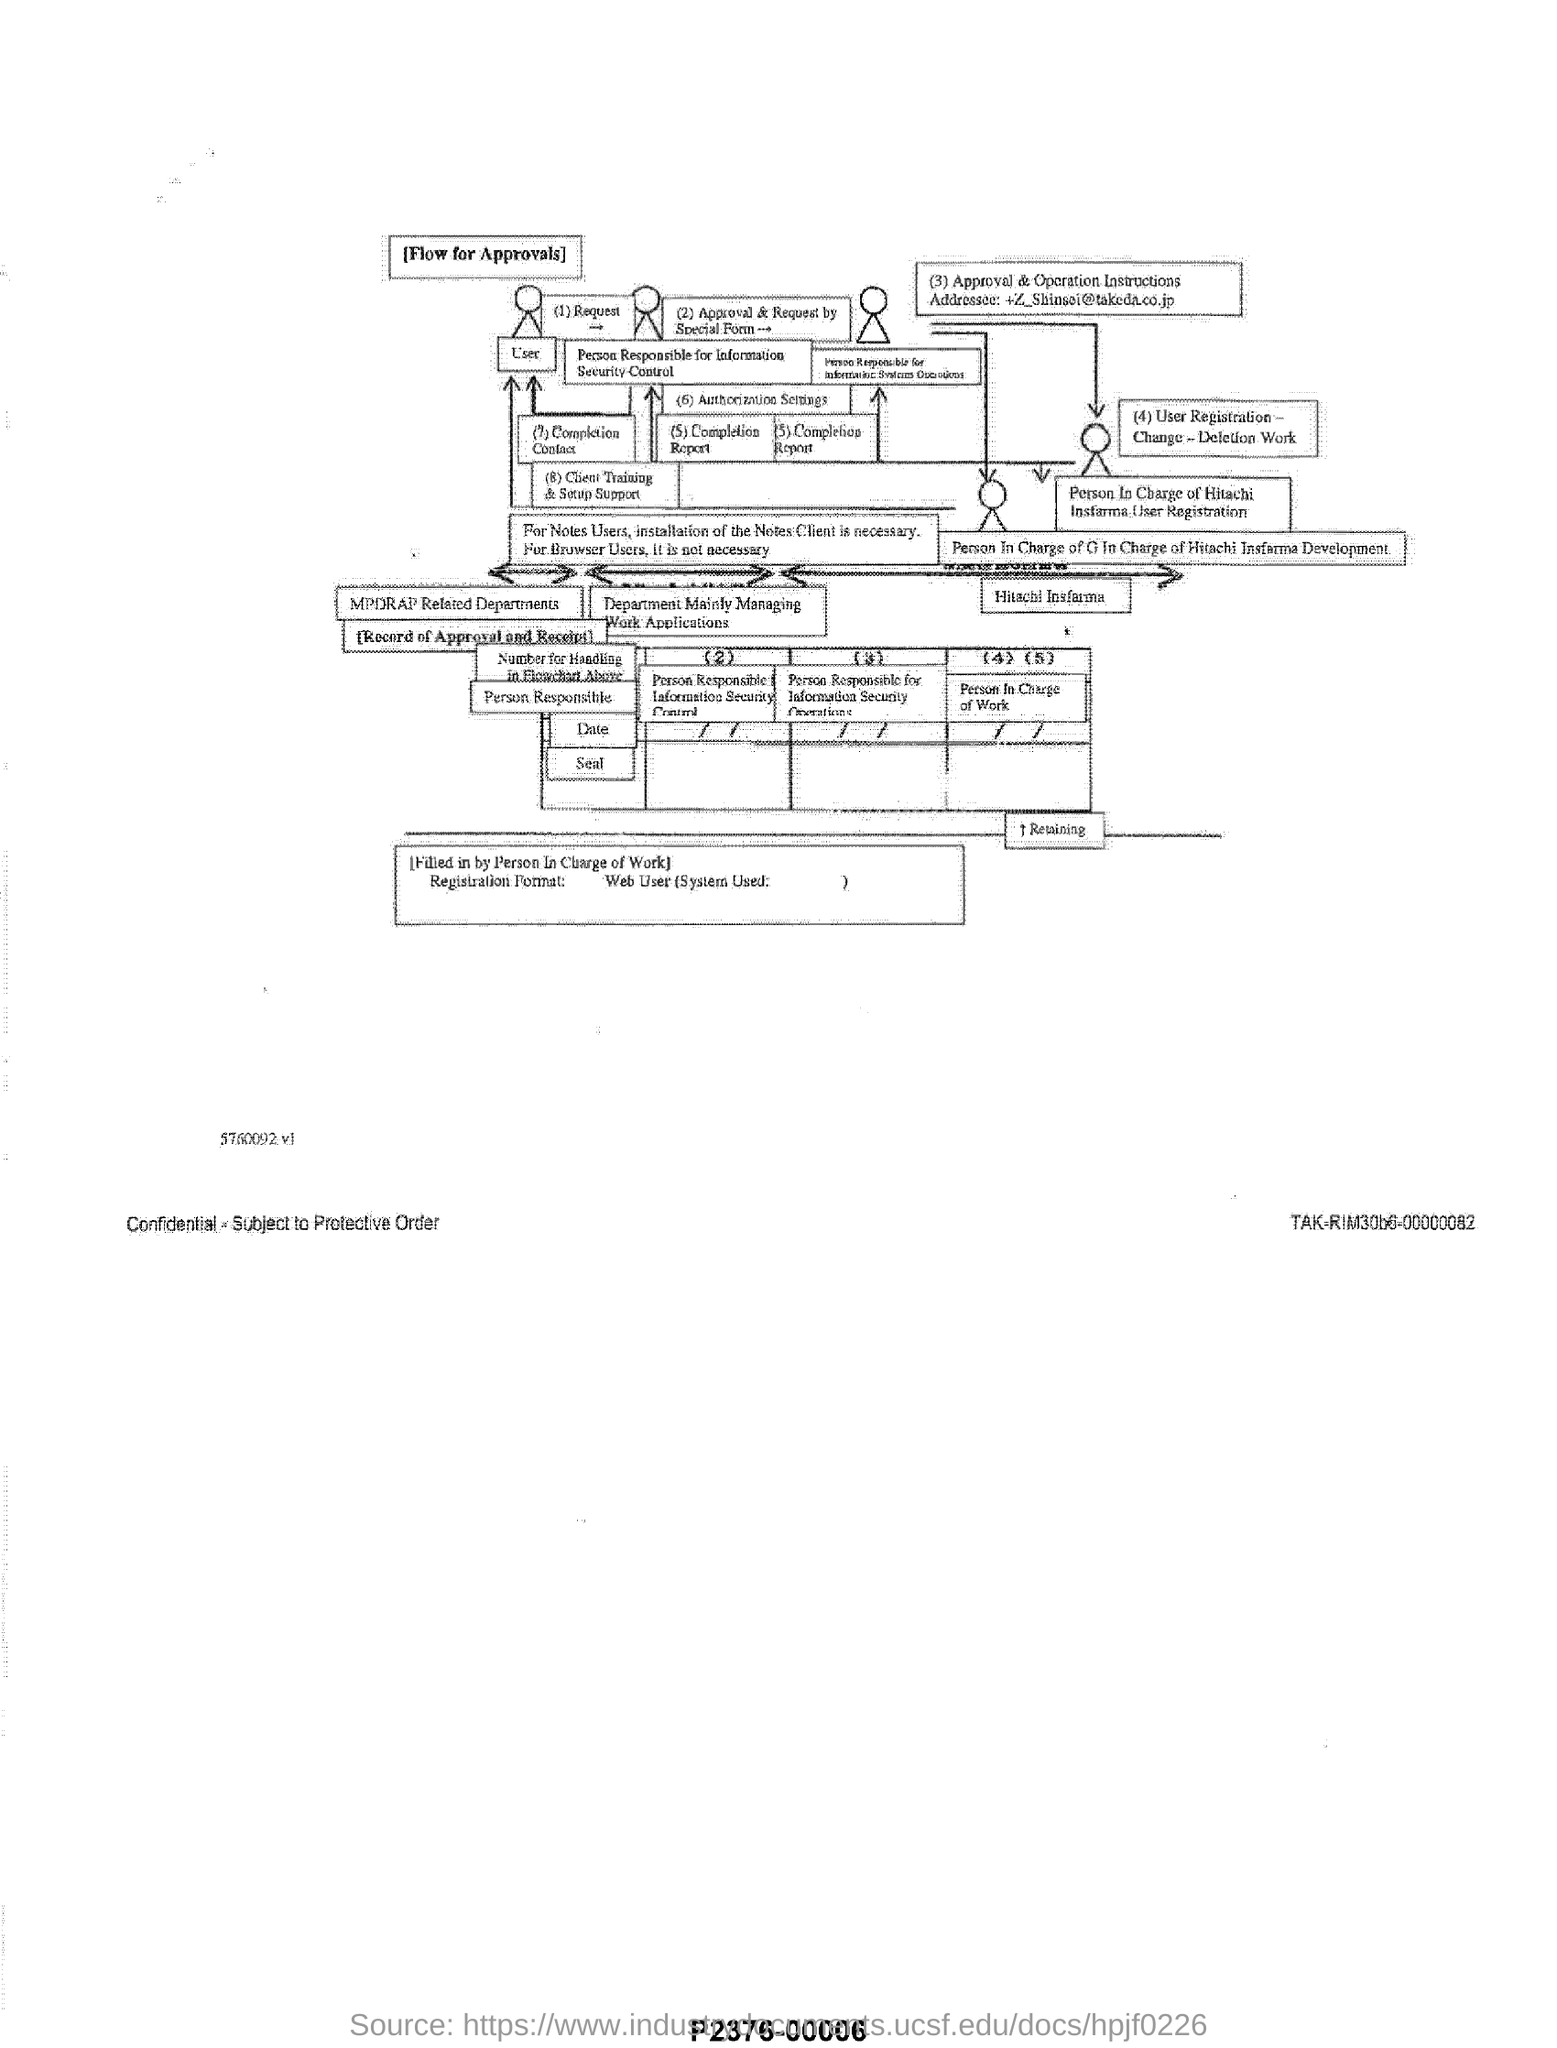What is this flowchart about?
Your response must be concise. [Flow for Approvals]. 